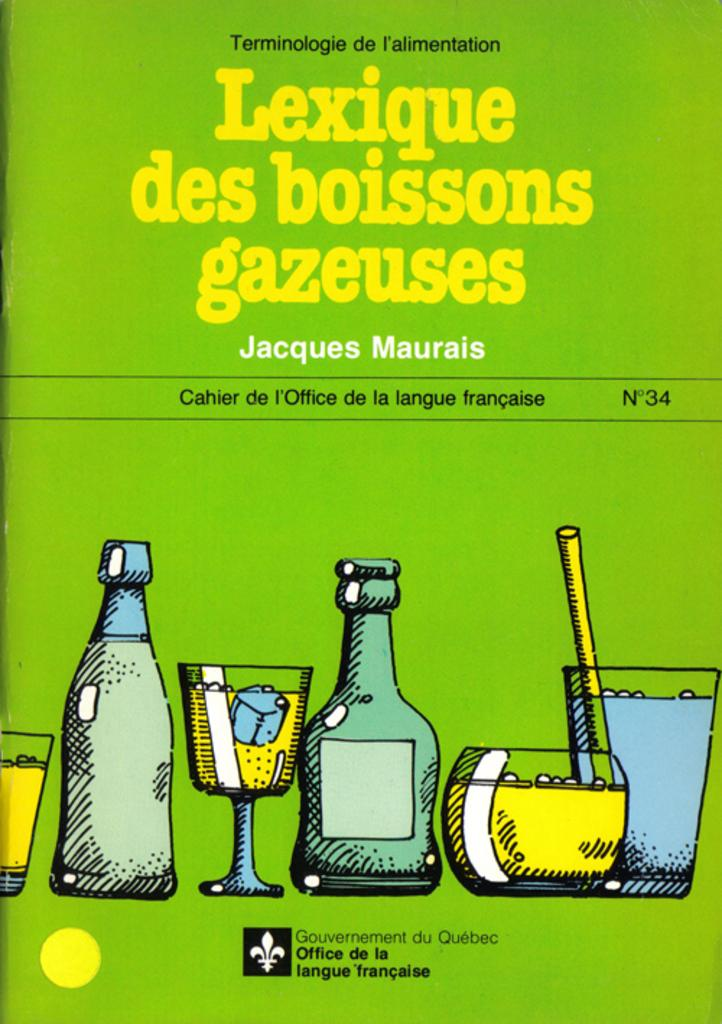<image>
Relay a brief, clear account of the picture shown. Jacques Maurais has written issue number 34 of this publication from the government of Quebec. 